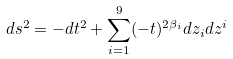<formula> <loc_0><loc_0><loc_500><loc_500>d s ^ { 2 } = - d t ^ { 2 } + \sum _ { i = 1 } ^ { 9 } ( - t ) ^ { 2 \beta _ { i } } d z _ { i } d z ^ { i }</formula> 